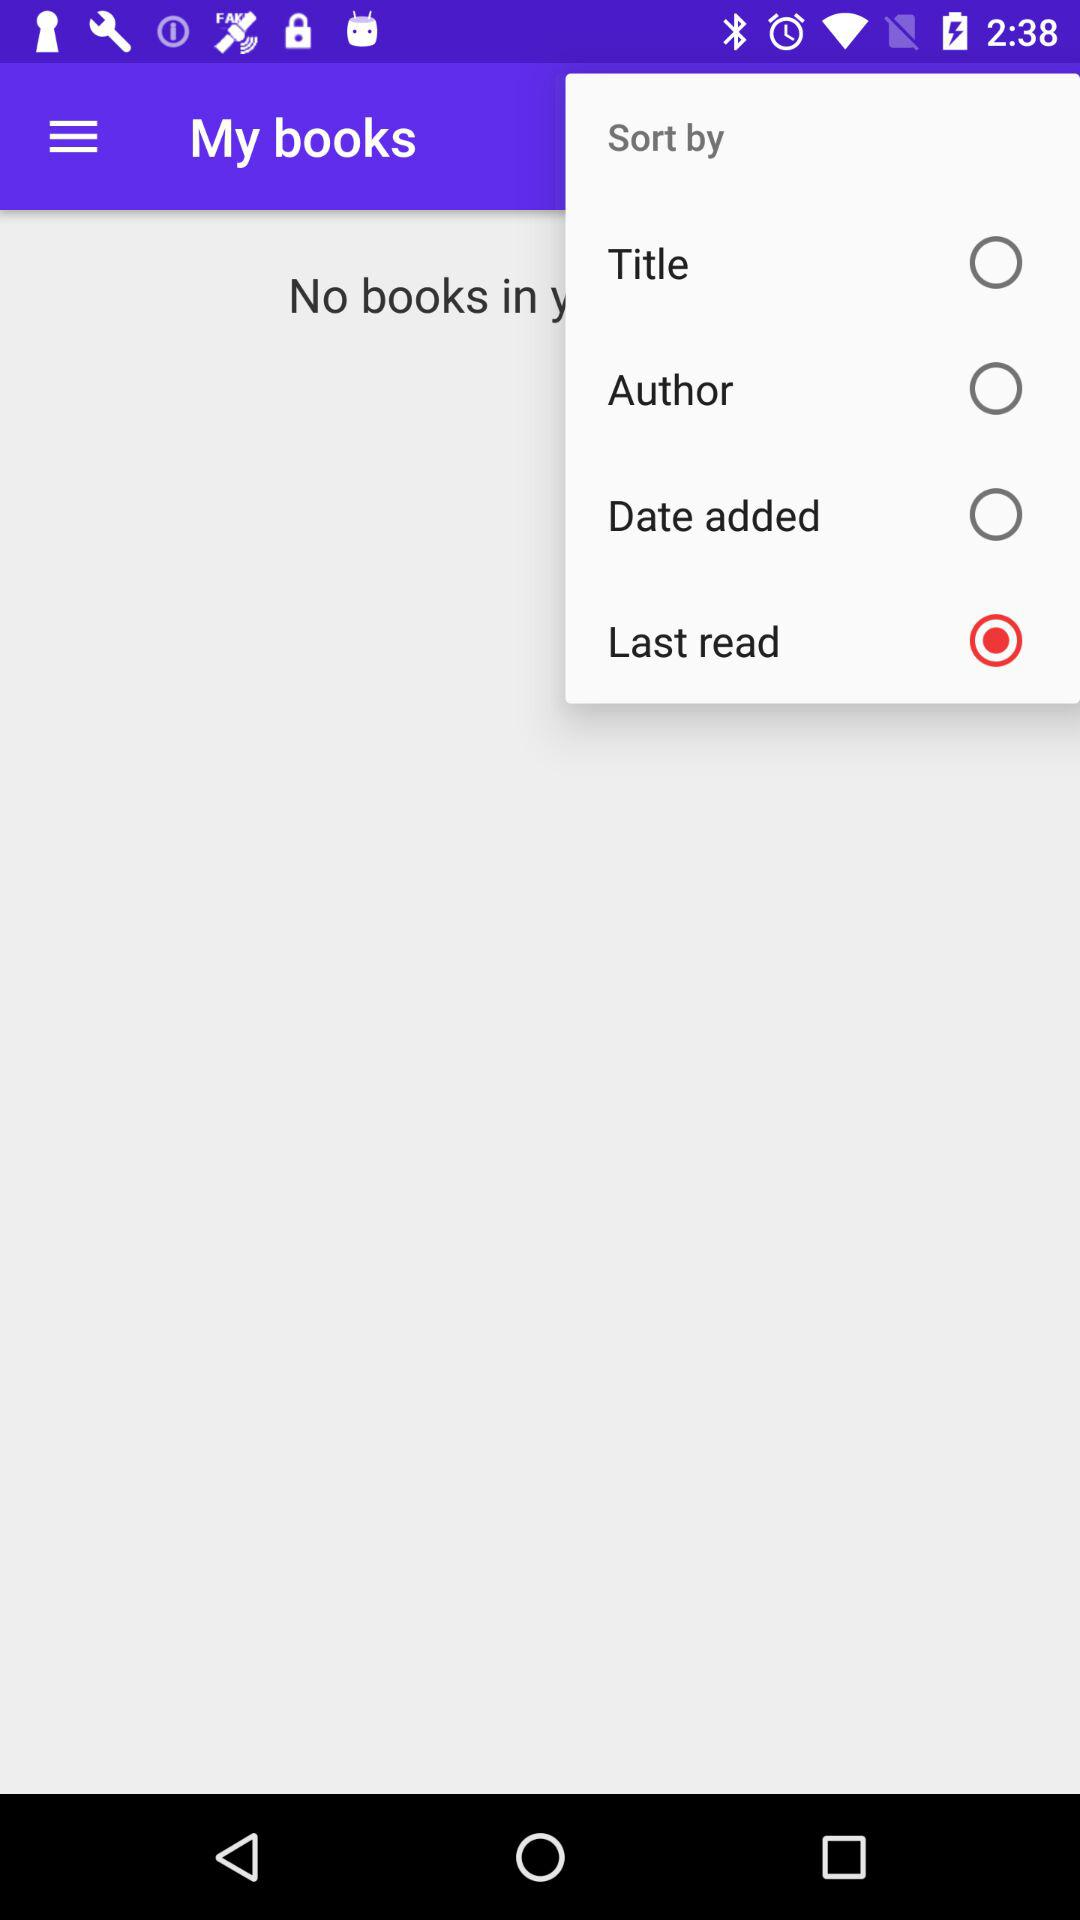Which option is chosen for sorting? The option chosen for sorting is "Last read". 